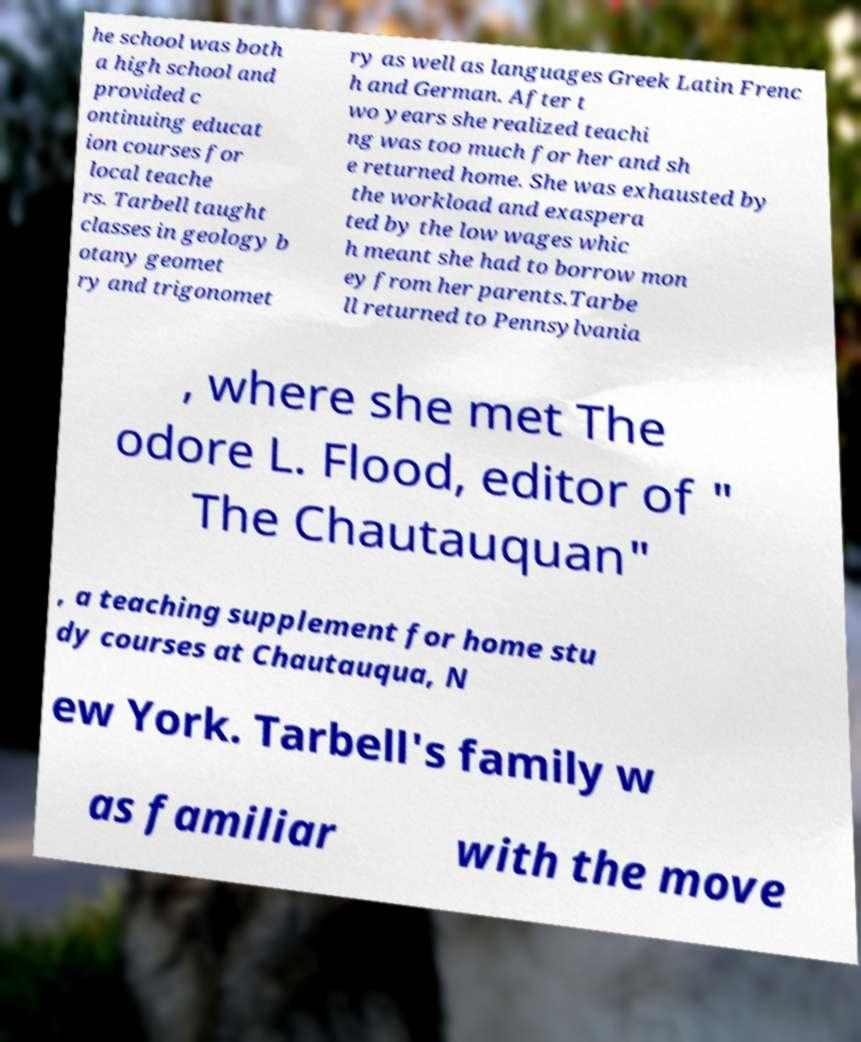I need the written content from this picture converted into text. Can you do that? he school was both a high school and provided c ontinuing educat ion courses for local teache rs. Tarbell taught classes in geology b otany geomet ry and trigonomet ry as well as languages Greek Latin Frenc h and German. After t wo years she realized teachi ng was too much for her and sh e returned home. She was exhausted by the workload and exaspera ted by the low wages whic h meant she had to borrow mon ey from her parents.Tarbe ll returned to Pennsylvania , where she met The odore L. Flood, editor of " The Chautauquan" , a teaching supplement for home stu dy courses at Chautauqua, N ew York. Tarbell's family w as familiar with the move 